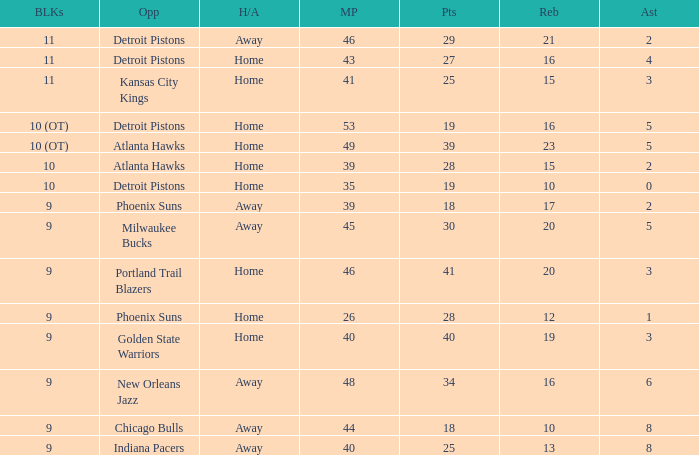How many minutes were played when there were 18 points and the opponent was Chicago Bulls? 1.0. 